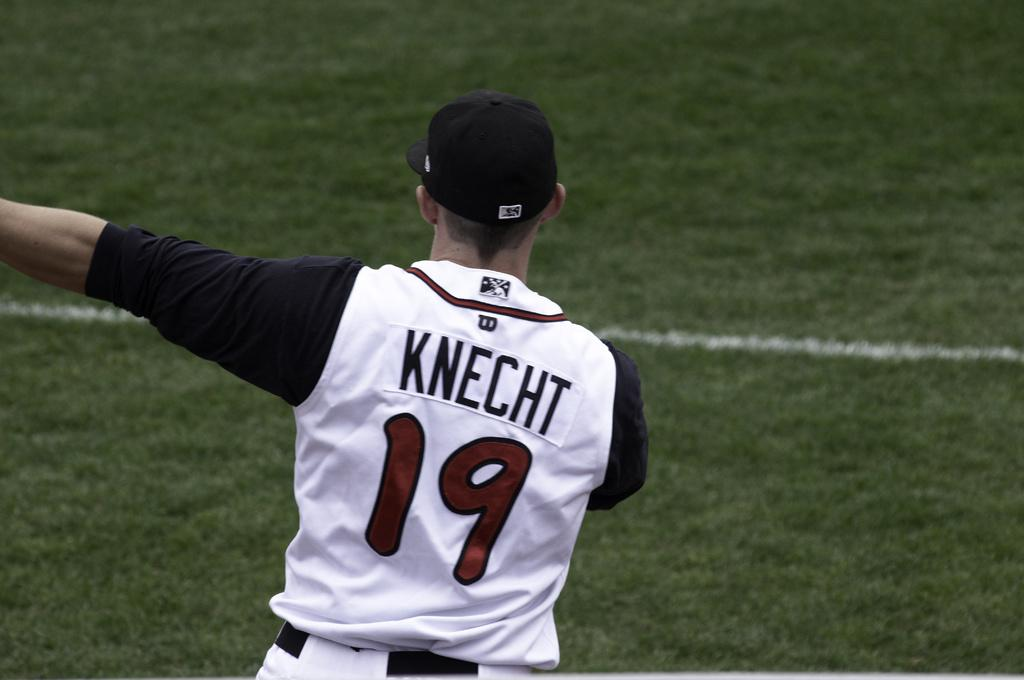<image>
Write a terse but informative summary of the picture. Major League Baseball player Knecht gestures to the left. 